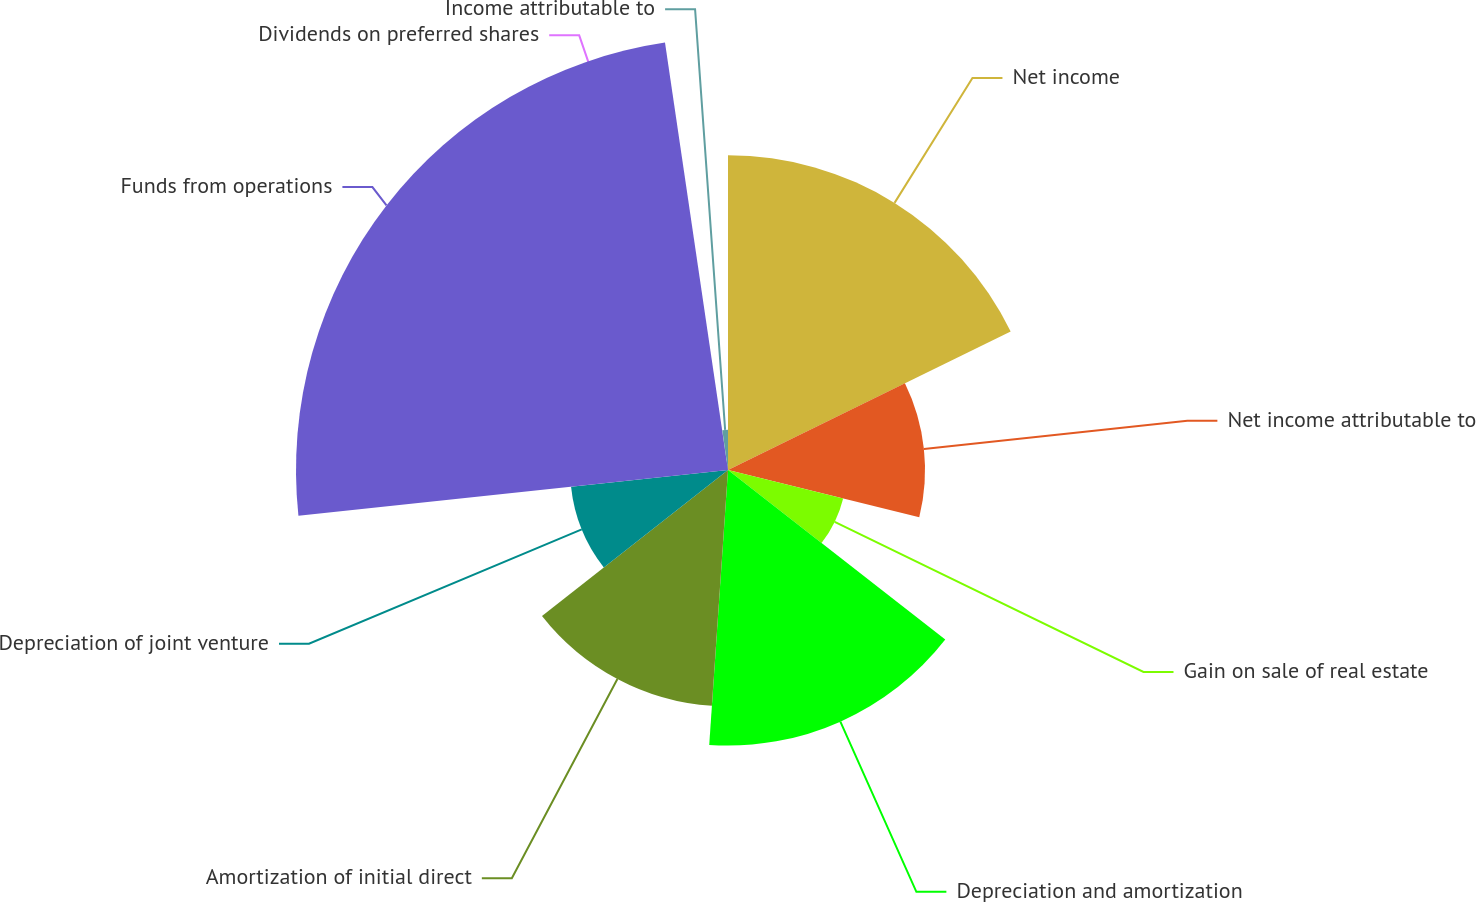Convert chart to OTSL. <chart><loc_0><loc_0><loc_500><loc_500><pie_chart><fcel>Net income<fcel>Net income attributable to<fcel>Gain on sale of real estate<fcel>Depreciation and amortization<fcel>Amortization of initial direct<fcel>Depreciation of joint venture<fcel>Funds from operations<fcel>Dividends on preferred shares<fcel>Income attributable to<nl><fcel>17.75%<fcel>11.11%<fcel>6.69%<fcel>15.54%<fcel>13.33%<fcel>8.9%<fcel>24.36%<fcel>0.06%<fcel>2.27%<nl></chart> 